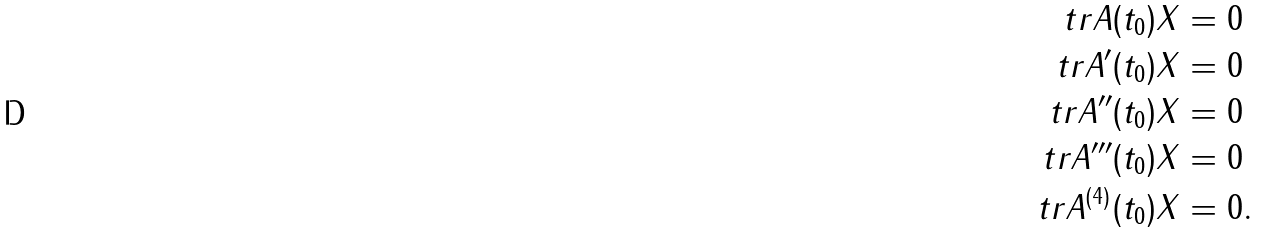Convert formula to latex. <formula><loc_0><loc_0><loc_500><loc_500>\ t r A ( t _ { 0 } ) X & = 0 \\ \ t r A ^ { \prime } ( t _ { 0 } ) X & = 0 \\ \ t r A ^ { \prime \prime } ( t _ { 0 } ) X & = 0 \\ \ t r A ^ { \prime \prime \prime } ( t _ { 0 } ) X & = 0 \\ \ t r A ^ { ( 4 ) } ( t _ { 0 } ) X & = 0 .</formula> 